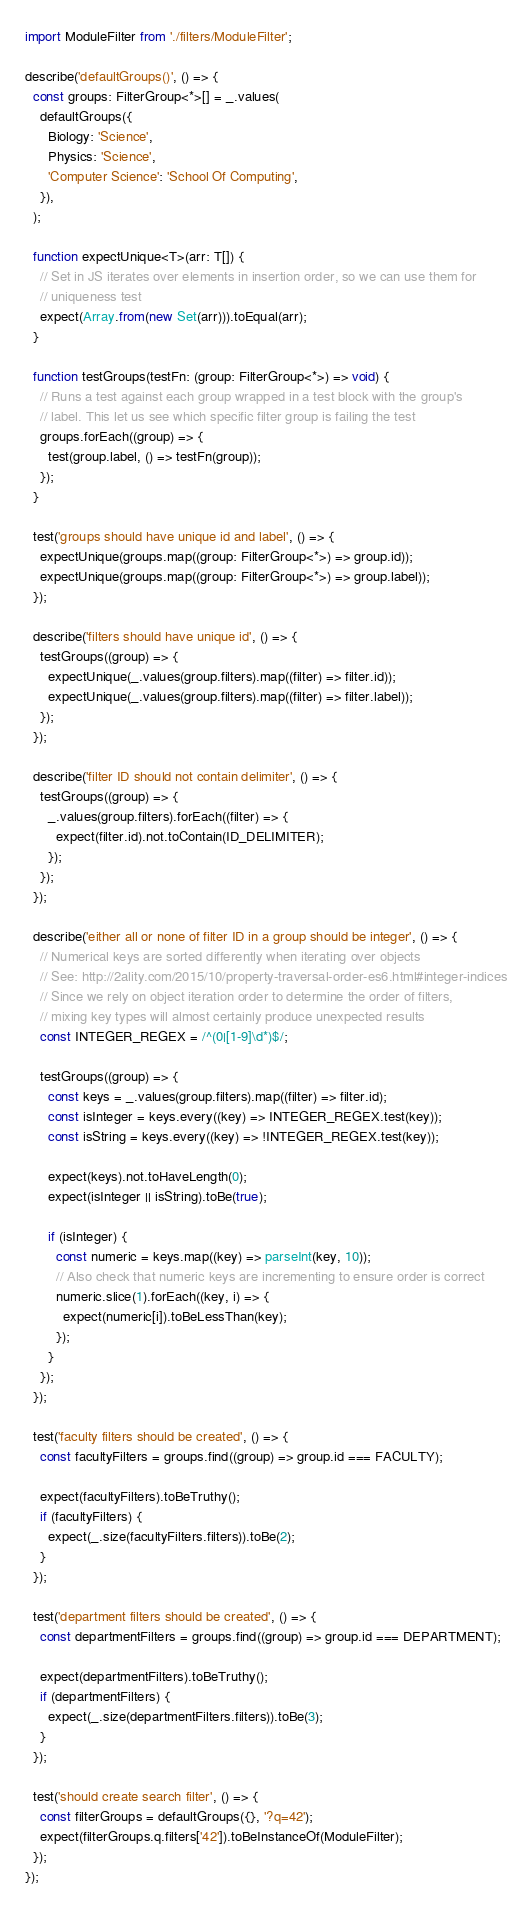<code> <loc_0><loc_0><loc_500><loc_500><_JavaScript_>import ModuleFilter from './filters/ModuleFilter';

describe('defaultGroups()', () => {
  const groups: FilterGroup<*>[] = _.values(
    defaultGroups({
      Biology: 'Science',
      Physics: 'Science',
      'Computer Science': 'School Of Computing',
    }),
  );

  function expectUnique<T>(arr: T[]) {
    // Set in JS iterates over elements in insertion order, so we can use them for
    // uniqueness test
    expect(Array.from(new Set(arr))).toEqual(arr);
  }

  function testGroups(testFn: (group: FilterGroup<*>) => void) {
    // Runs a test against each group wrapped in a test block with the group's
    // label. This let us see which specific filter group is failing the test
    groups.forEach((group) => {
      test(group.label, () => testFn(group));
    });
  }

  test('groups should have unique id and label', () => {
    expectUnique(groups.map((group: FilterGroup<*>) => group.id));
    expectUnique(groups.map((group: FilterGroup<*>) => group.label));
  });

  describe('filters should have unique id', () => {
    testGroups((group) => {
      expectUnique(_.values(group.filters).map((filter) => filter.id));
      expectUnique(_.values(group.filters).map((filter) => filter.label));
    });
  });

  describe('filter ID should not contain delimiter', () => {
    testGroups((group) => {
      _.values(group.filters).forEach((filter) => {
        expect(filter.id).not.toContain(ID_DELIMITER);
      });
    });
  });

  describe('either all or none of filter ID in a group should be integer', () => {
    // Numerical keys are sorted differently when iterating over objects
    // See: http://2ality.com/2015/10/property-traversal-order-es6.html#integer-indices
    // Since we rely on object iteration order to determine the order of filters,
    // mixing key types will almost certainly produce unexpected results
    const INTEGER_REGEX = /^(0|[1-9]\d*)$/;

    testGroups((group) => {
      const keys = _.values(group.filters).map((filter) => filter.id);
      const isInteger = keys.every((key) => INTEGER_REGEX.test(key));
      const isString = keys.every((key) => !INTEGER_REGEX.test(key));

      expect(keys).not.toHaveLength(0);
      expect(isInteger || isString).toBe(true);

      if (isInteger) {
        const numeric = keys.map((key) => parseInt(key, 10));
        // Also check that numeric keys are incrementing to ensure order is correct
        numeric.slice(1).forEach((key, i) => {
          expect(numeric[i]).toBeLessThan(key);
        });
      }
    });
  });

  test('faculty filters should be created', () => {
    const facultyFilters = groups.find((group) => group.id === FACULTY);

    expect(facultyFilters).toBeTruthy();
    if (facultyFilters) {
      expect(_.size(facultyFilters.filters)).toBe(2);
    }
  });

  test('department filters should be created', () => {
    const departmentFilters = groups.find((group) => group.id === DEPARTMENT);

    expect(departmentFilters).toBeTruthy();
    if (departmentFilters) {
      expect(_.size(departmentFilters.filters)).toBe(3);
    }
  });

  test('should create search filter', () => {
    const filterGroups = defaultGroups({}, '?q=42');
    expect(filterGroups.q.filters['42']).toBeInstanceOf(ModuleFilter);
  });
});
</code> 